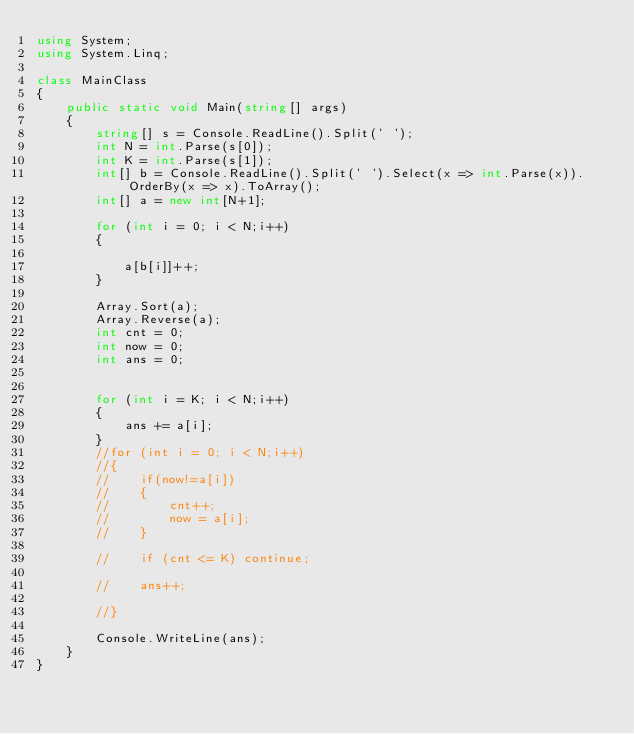<code> <loc_0><loc_0><loc_500><loc_500><_C#_>using System;
using System.Linq;

class MainClass
{
    public static void Main(string[] args)
    {
        string[] s = Console.ReadLine().Split(' ');
        int N = int.Parse(s[0]);
        int K = int.Parse(s[1]);
        int[] b = Console.ReadLine().Split(' ').Select(x => int.Parse(x)).OrderBy(x => x).ToArray();
        int[] a = new int[N+1];

        for (int i = 0; i < N;i++)
        {
            
            a[b[i]]++;
        }

        Array.Sort(a);
        Array.Reverse(a);
        int cnt = 0;
        int now = 0;
        int ans = 0;


        for (int i = K; i < N;i++)
        {
            ans += a[i];
        }
        //for (int i = 0; i < N;i++)
        //{
        //    if(now!=a[i])
        //    {
        //        cnt++;
        //        now = a[i];
        //    }

        //    if (cnt <= K) continue;

        //    ans++;

        //}

        Console.WriteLine(ans);
    }
}</code> 